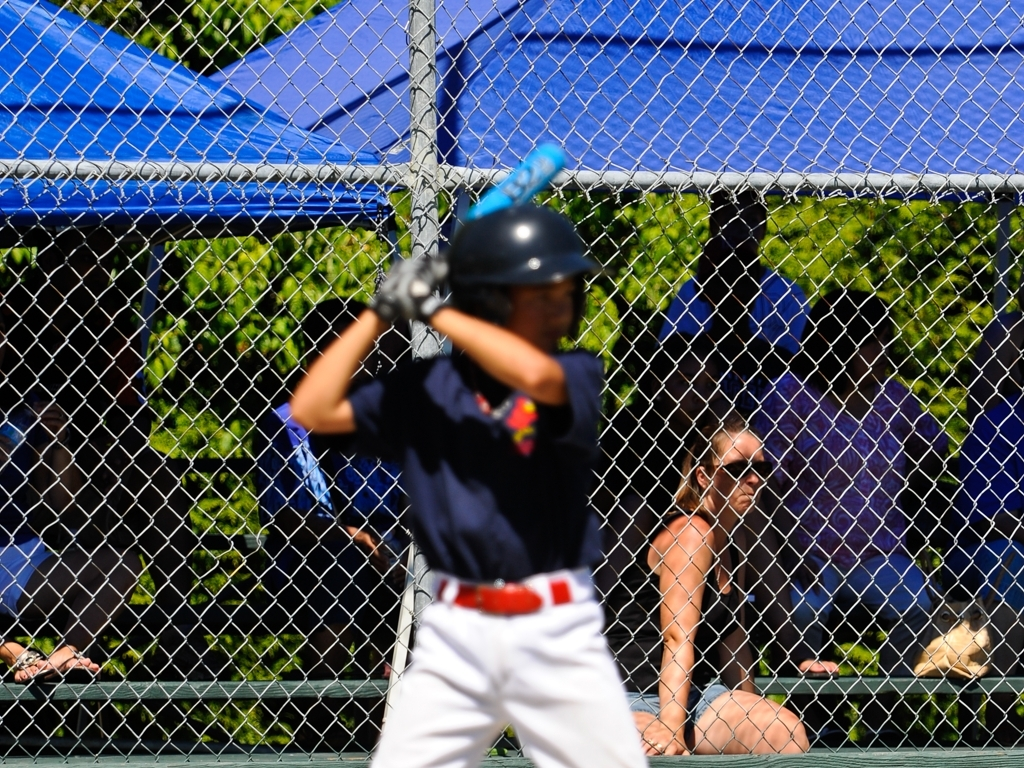Is there a problem with focus in this photo? Indeed, there is an issue with focus in this image; the center of attention is on the chain-link fence in the foreground, while the baseball player in the mid-ground is notably out of focus. This could be due to an intentional artistic choice or an accidental misadjustment of the camera's focus setting. 